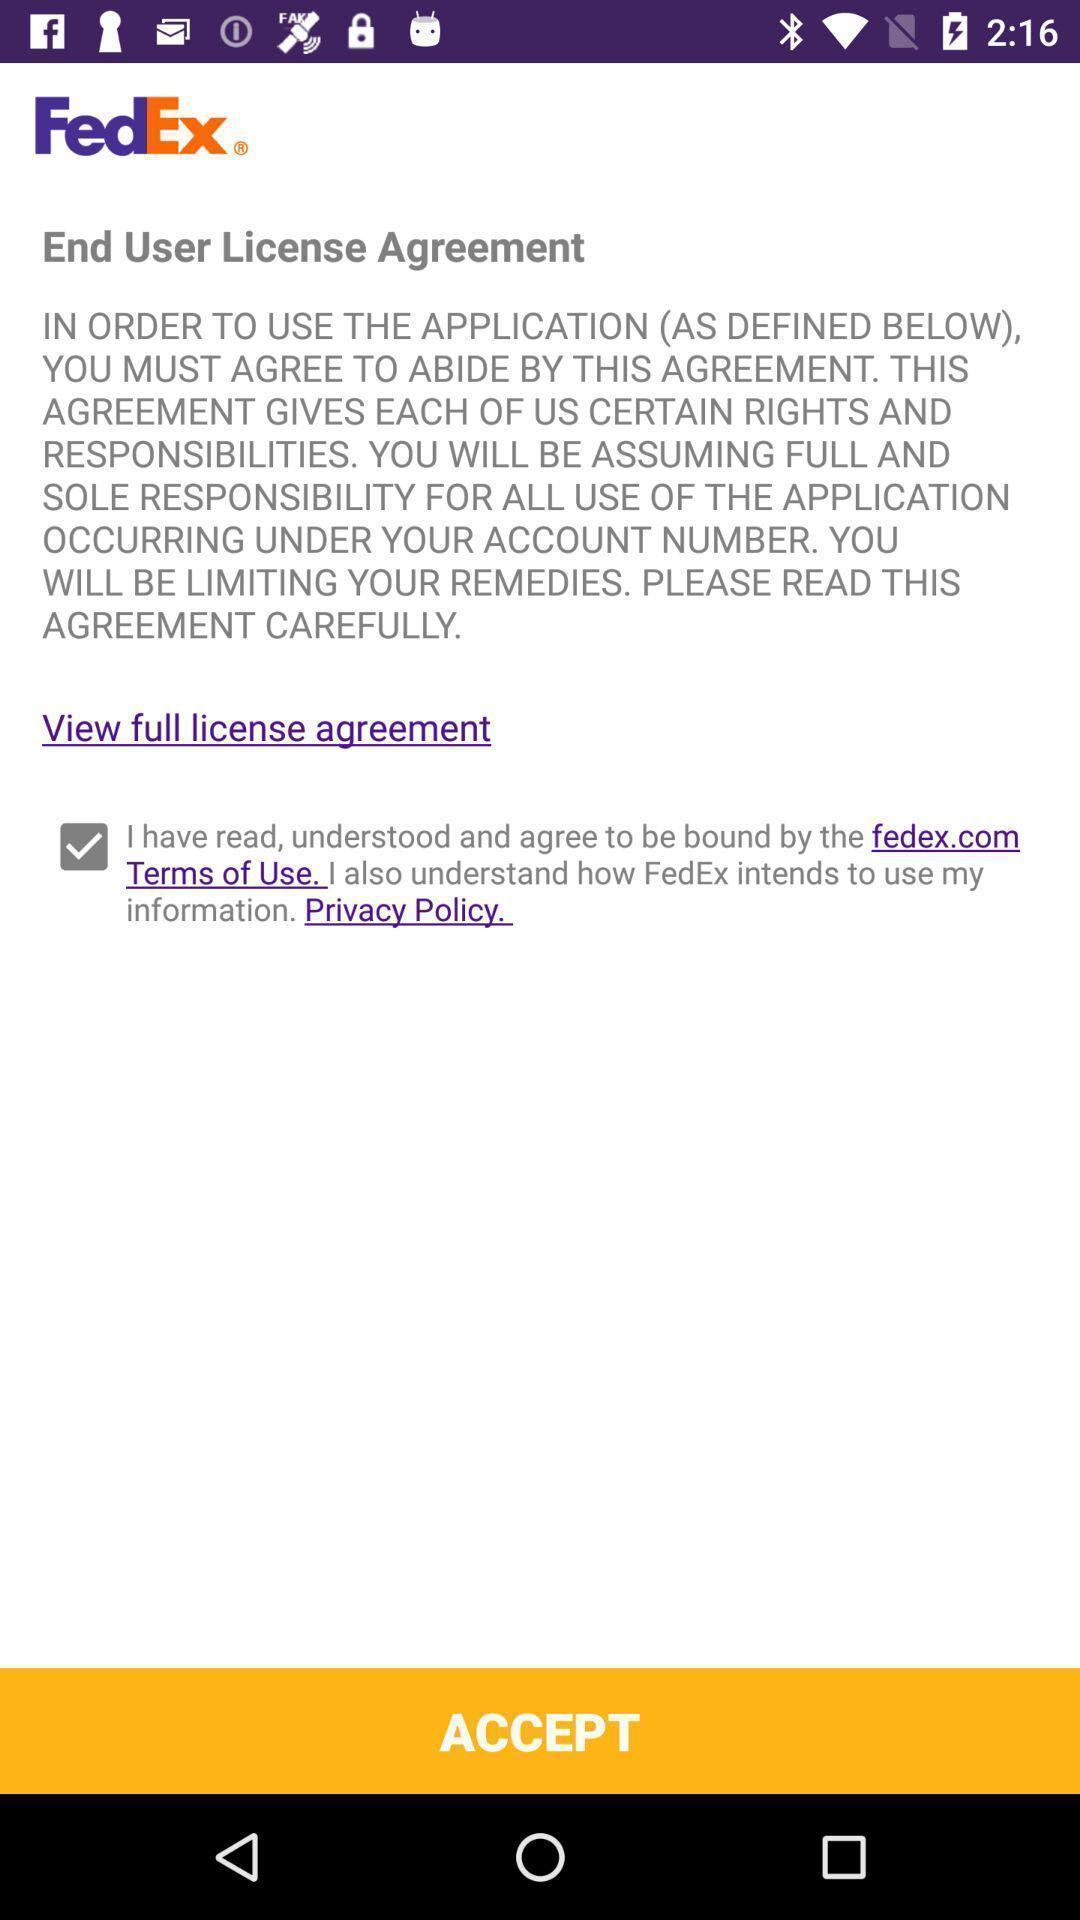Summarize the main components in this picture. Page to accept terms of use in the shipping app. 